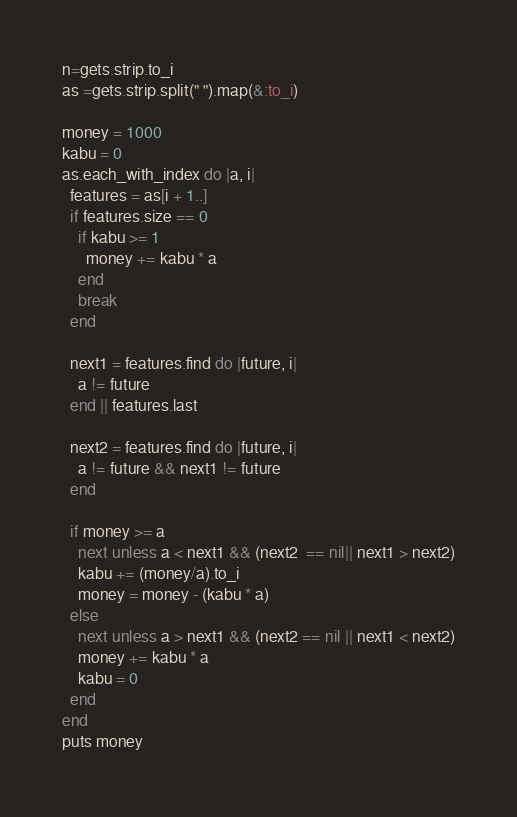Convert code to text. <code><loc_0><loc_0><loc_500><loc_500><_Ruby_>n=gets.strip.to_i
as =gets.strip.split(" ").map(&:to_i)

money = 1000
kabu = 0
as.each_with_index do |a, i|
  features = as[i + 1..]
  if features.size == 0
    if kabu >= 1
      money += kabu * a
    end
    break
  end

  next1 = features.find do |future, i|
    a != future
  end || features.last

  next2 = features.find do |future, i|
    a != future && next1 != future
  end

  if money >= a
    next unless a < next1 && (next2  == nil|| next1 > next2)
    kabu += (money/a).to_i
    money = money - (kabu * a)
  else
    next unless a > next1 && (next2 == nil || next1 < next2)
    money += kabu * a
    kabu = 0
  end
end
puts money
</code> 